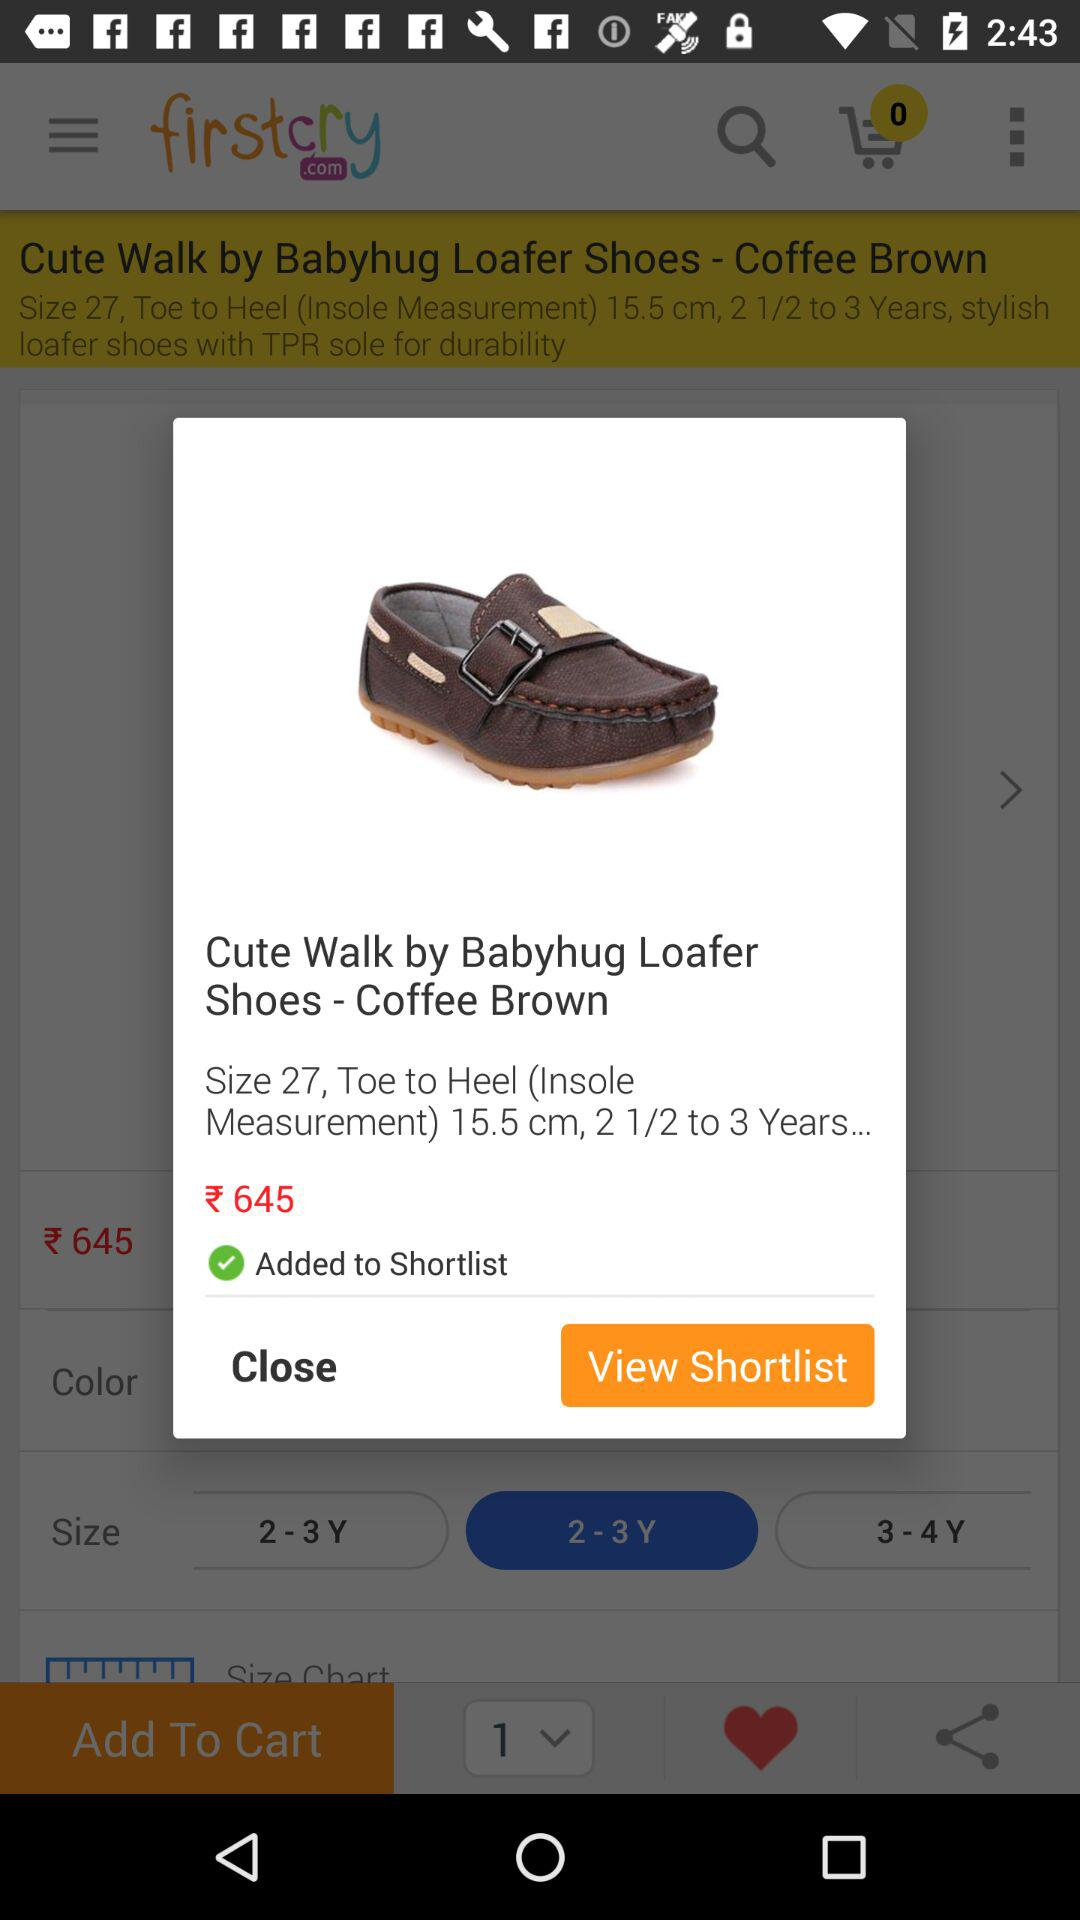What is the selling price of the shoes? The selling price of the shoes is ₹645. 